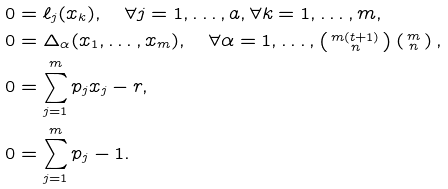<formula> <loc_0><loc_0><loc_500><loc_500>0 & = \ell _ { j } ( x _ { k } ) , \quad \forall j = 1 , \dots , a , \forall k = 1 , \dots , m , \\ 0 & = \Delta _ { \alpha } ( x _ { 1 } , \dots , x _ { m } ) , \quad \forall \alpha = 1 , \dots , \left ( \begin{smallmatrix} m ( t + 1 ) \\ n \end{smallmatrix} \right ) \left ( \begin{smallmatrix} m \\ n \end{smallmatrix} \right ) , \\ 0 & = \sum _ { j = 1 } ^ { m } p _ { j } x _ { j } - r , \\ 0 & = \sum _ { j = 1 } ^ { m } p _ { j } - 1 .</formula> 